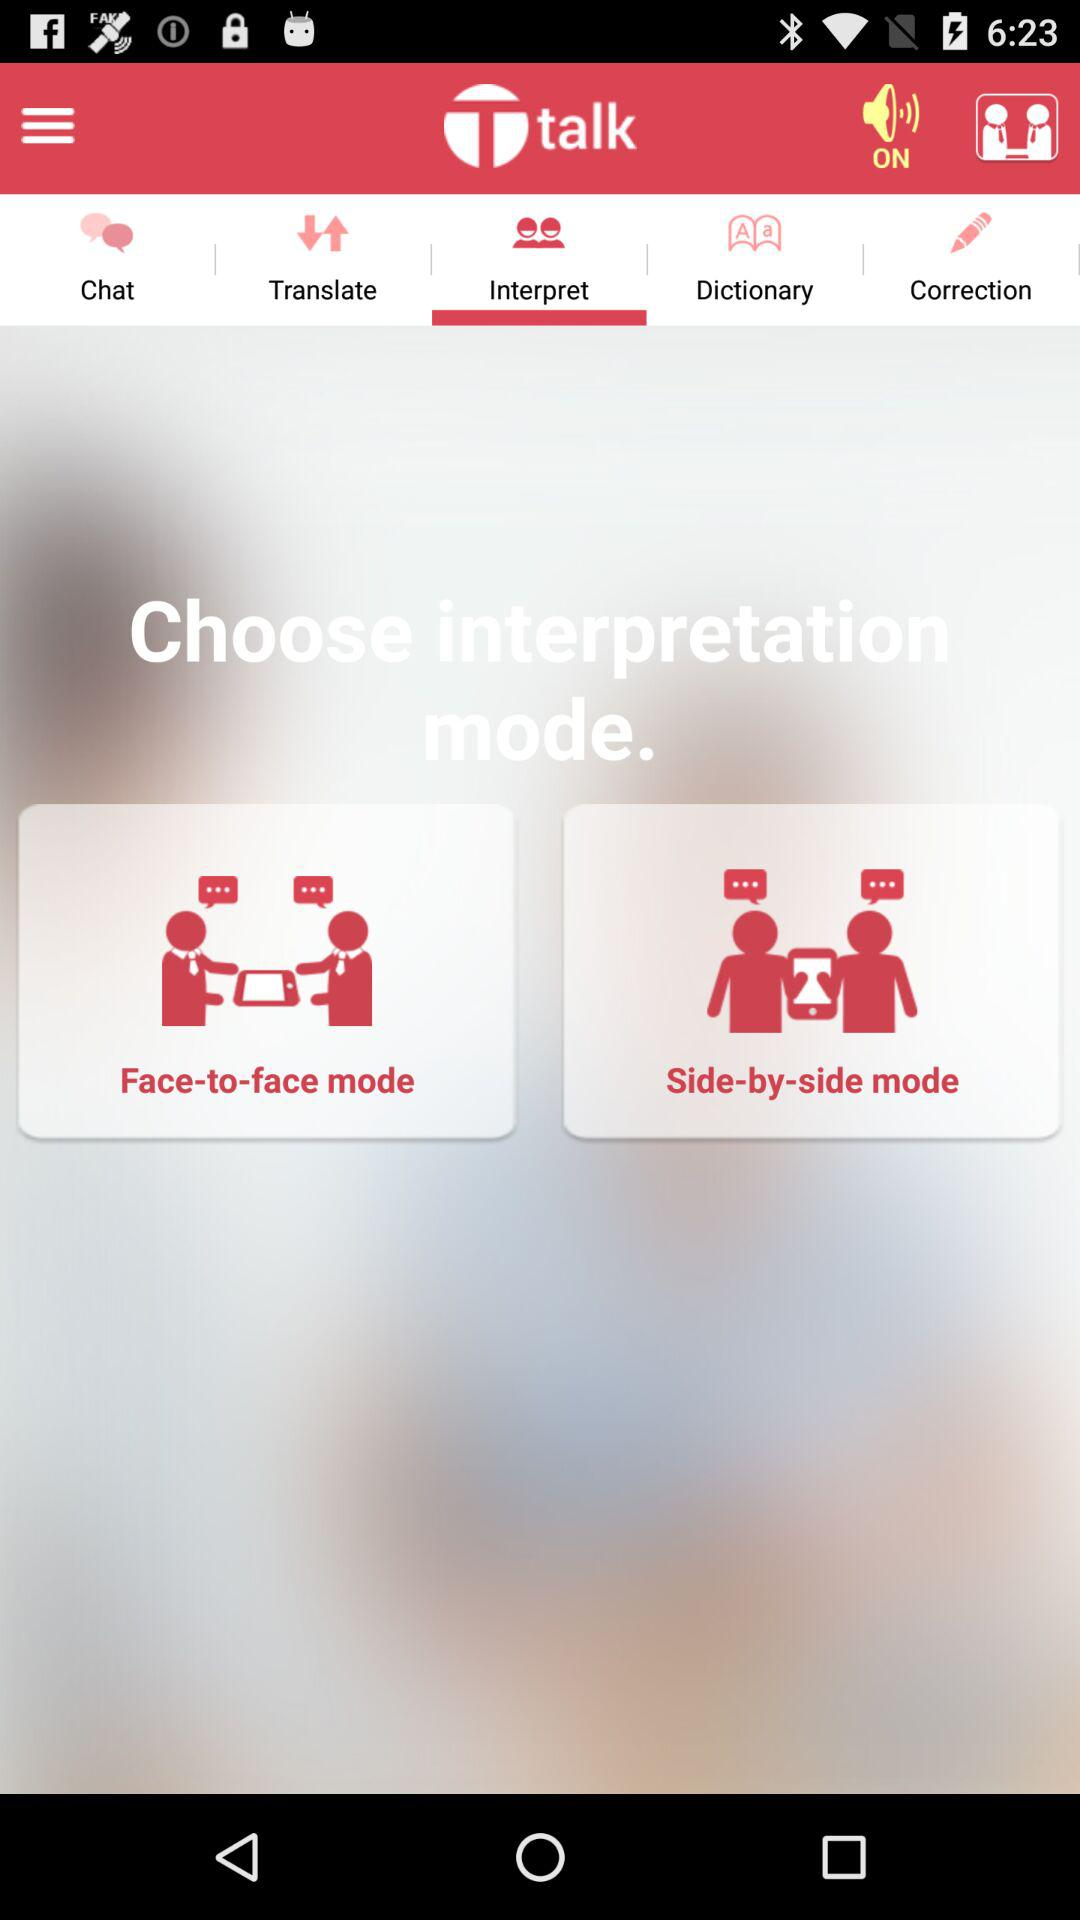What is the status of sound? The status is "on". 